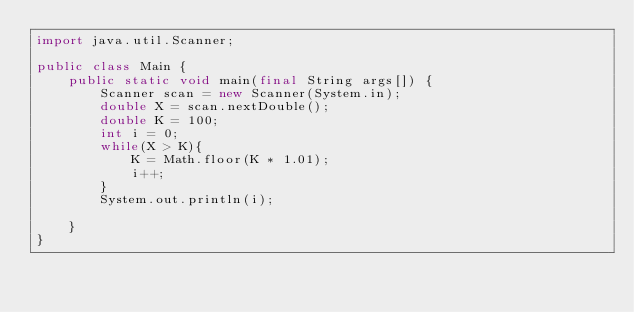Convert code to text. <code><loc_0><loc_0><loc_500><loc_500><_Java_>import java.util.Scanner;

public class Main {
    public static void main(final String args[]) {
        Scanner scan = new Scanner(System.in);
        double X = scan.nextDouble();
        double K = 100;
        int i = 0;
        while(X > K){
            K = Math.floor(K * 1.01);
            i++;
        }
        System.out.println(i);

    }
}
</code> 